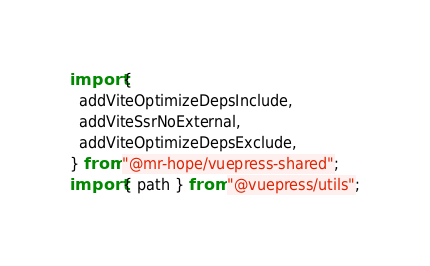<code> <loc_0><loc_0><loc_500><loc_500><_TypeScript_>import {
  addViteOptimizeDepsInclude,
  addViteSsrNoExternal,
  addViteOptimizeDepsExclude,
} from "@mr-hope/vuepress-shared";
import { path } from "@vuepress/utils";</code> 